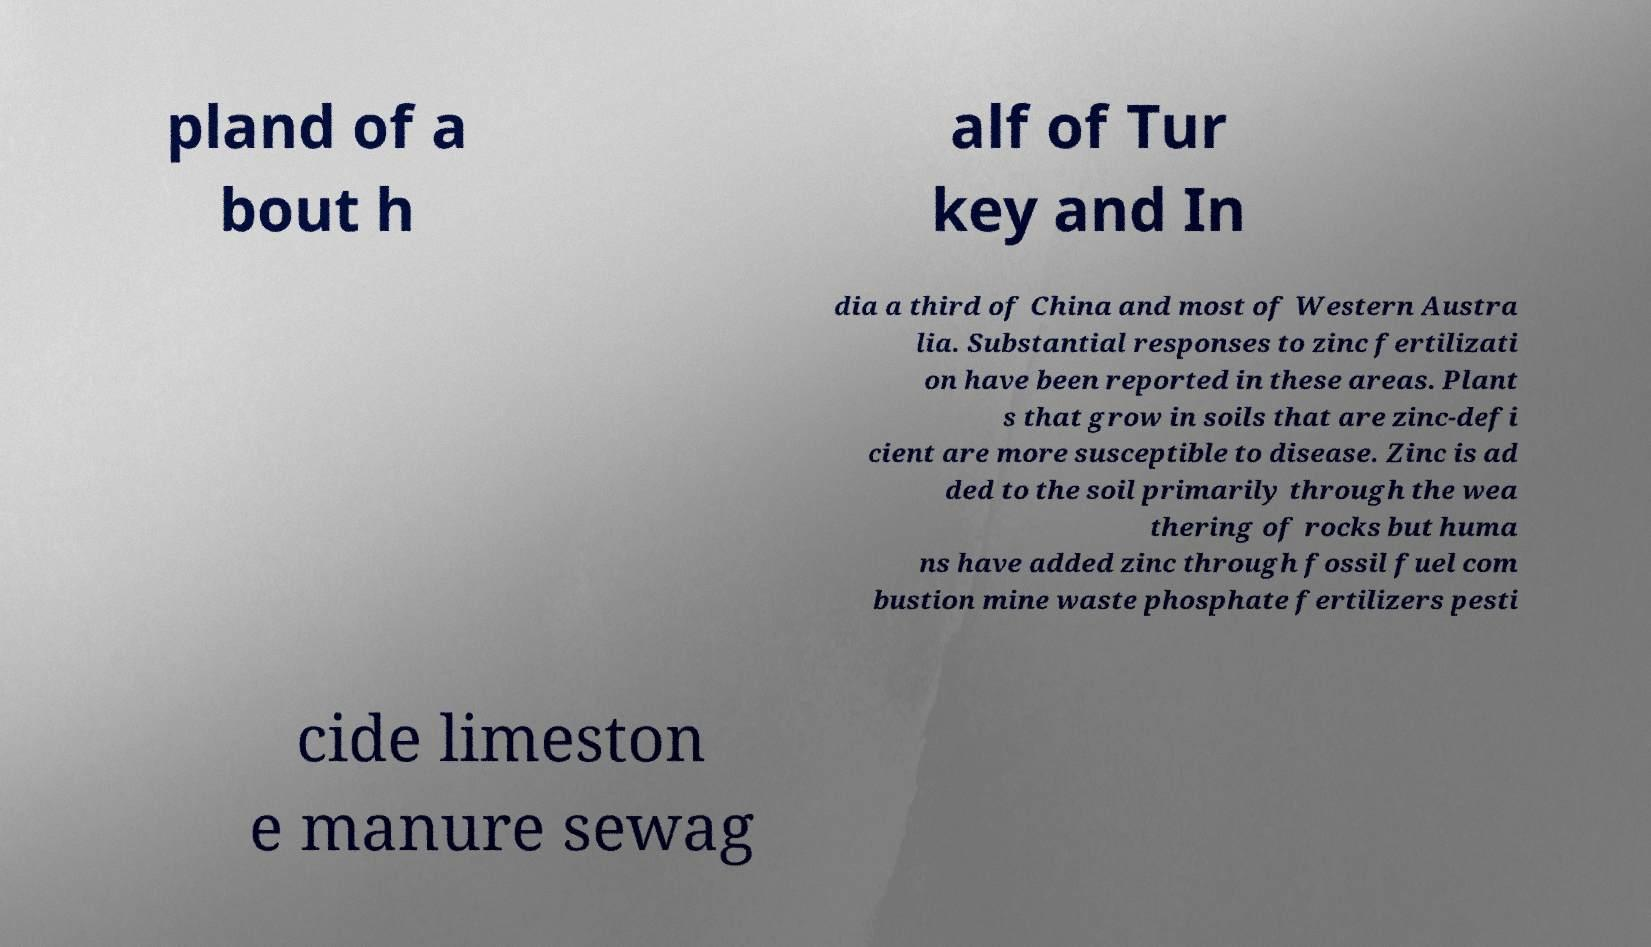Could you assist in decoding the text presented in this image and type it out clearly? pland of a bout h alf of Tur key and In dia a third of China and most of Western Austra lia. Substantial responses to zinc fertilizati on have been reported in these areas. Plant s that grow in soils that are zinc-defi cient are more susceptible to disease. Zinc is ad ded to the soil primarily through the wea thering of rocks but huma ns have added zinc through fossil fuel com bustion mine waste phosphate fertilizers pesti cide limeston e manure sewag 